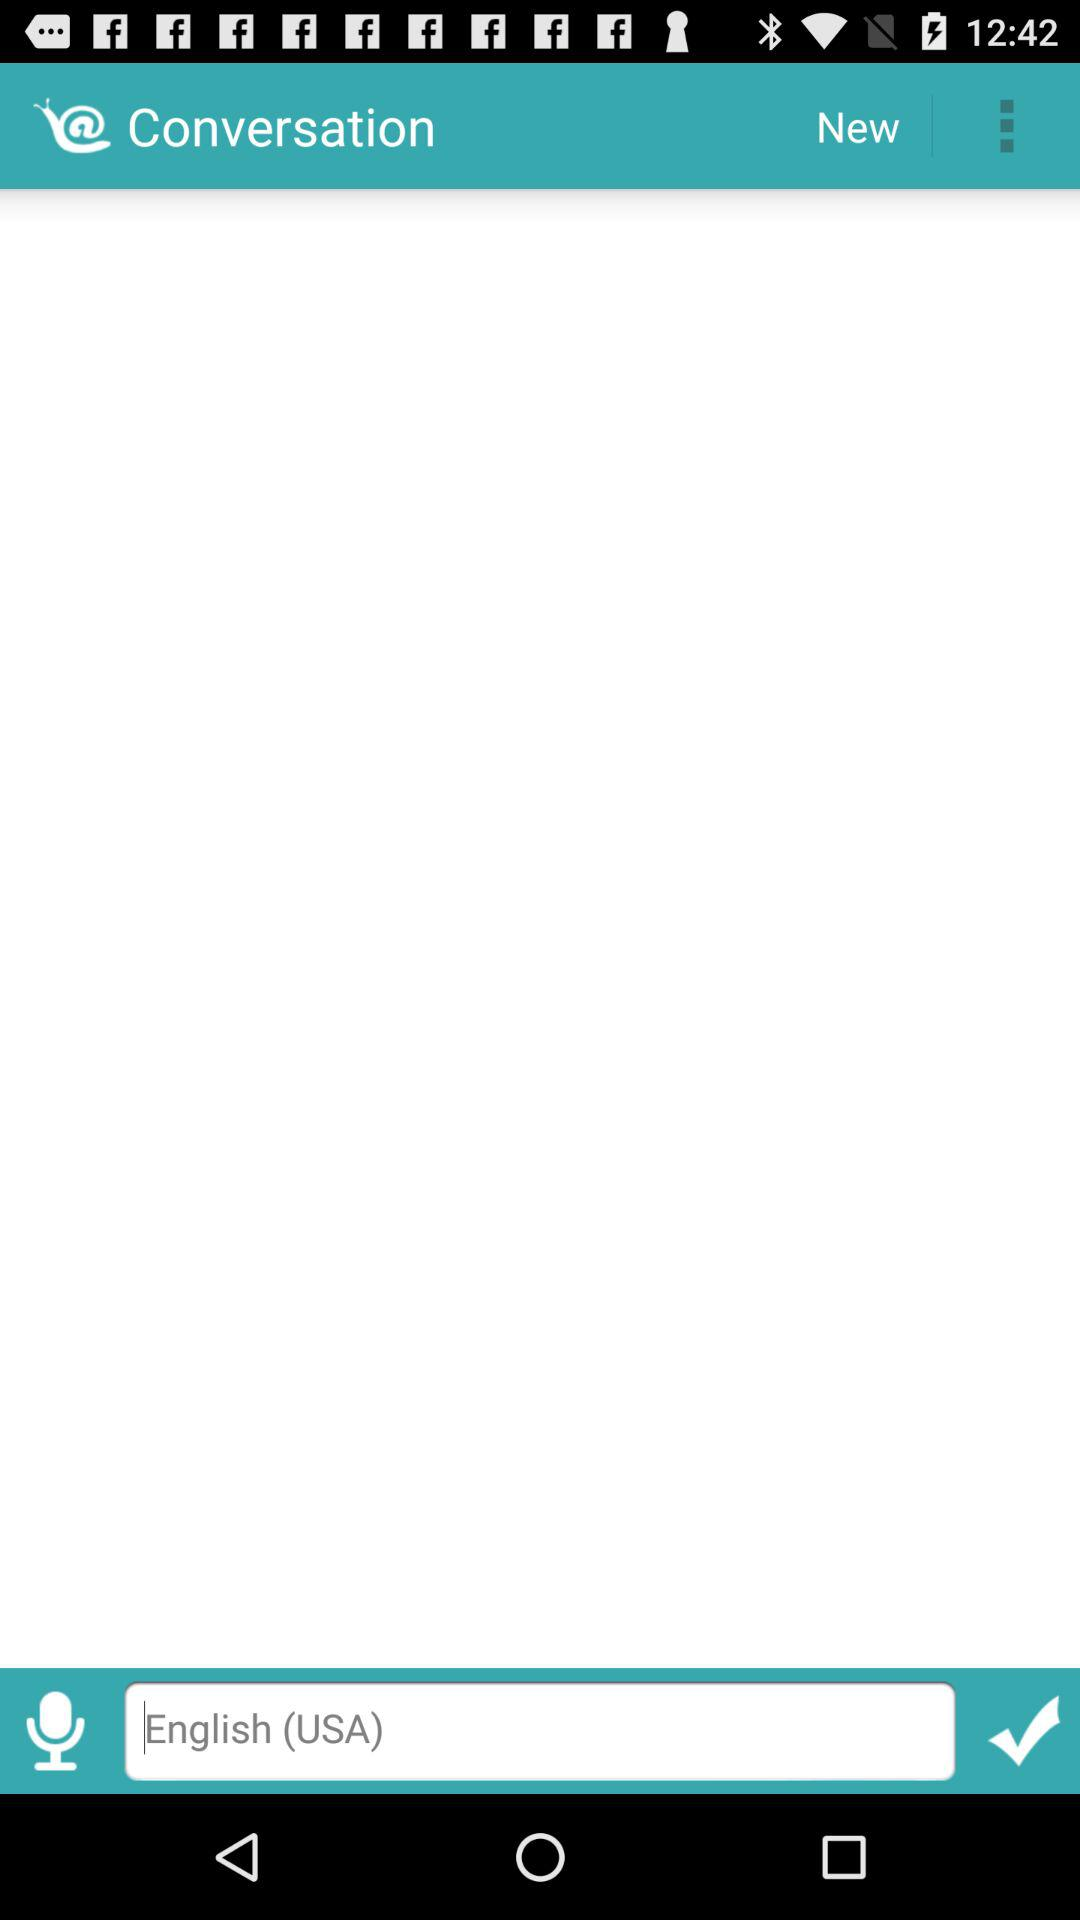What is the selected typing language? The selected typing language is English (USA). 